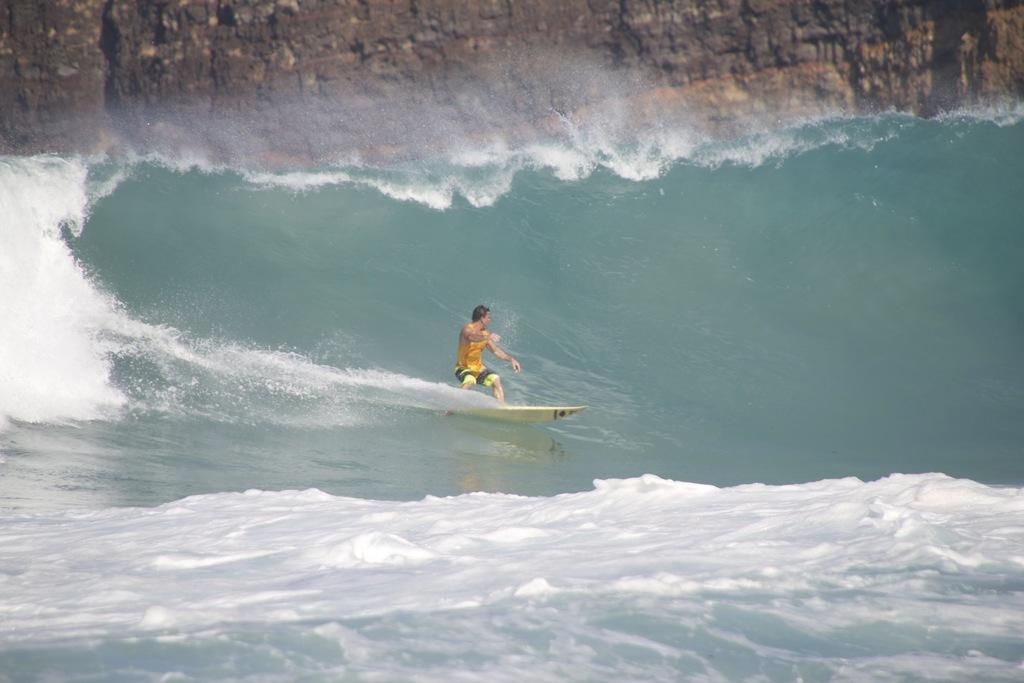What is the main subject of the image? There is a man in the image. What is the man doing in the image? The man is surfing on a surfboard. What type of clothing is the man wearing? The man is wearing shorts. What can be seen in the background of the image? There is water visible in the background of the image. What type of hill can be seen in the background of the image? There is no hill present in the image; it features a man surfing on a surfboard in water. 